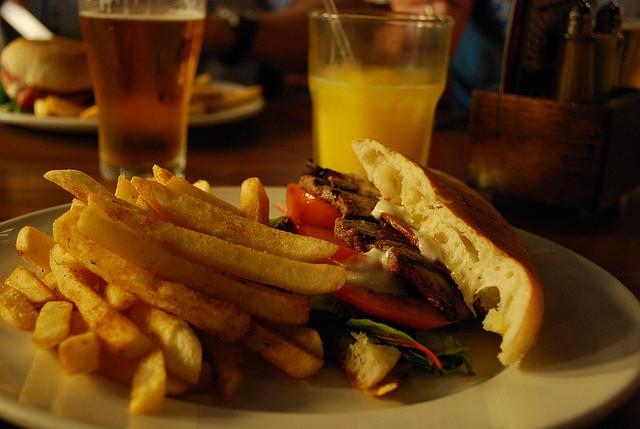Are the fries seasoned?
Short answer required. Yes. Is this a Sunkist orange soda?
Keep it brief. No. Is there a side dish?
Give a very brief answer. Yes. Are there any alcoholic beverages present?
Answer briefly. Yes. 